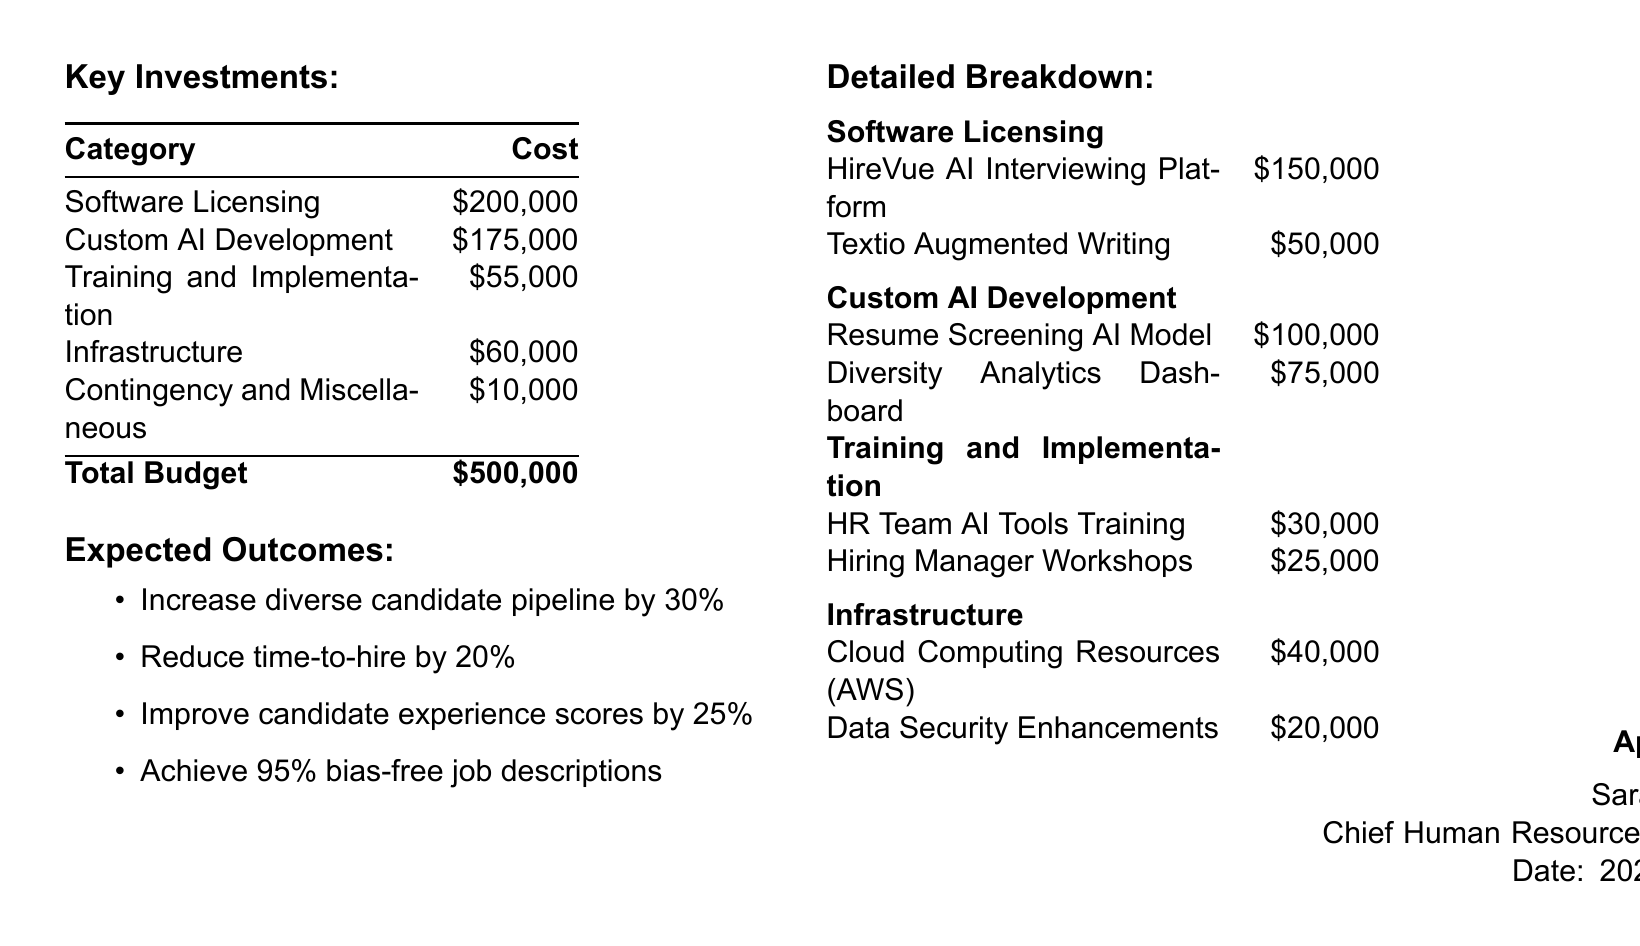What is the total budget? The total budget is presented at the bottom of the budget table.
Answer: $500,000 How much is allocated for Custom AI Development? The breakdown indicates the cost for Custom AI Development in the budget table.
Answer: $175,000 What is the cost for the HireVue AI Interviewing Platform? The cost for the HireVue AI Interviewing Platform is listed in the detailed breakdown.
Answer: $150,000 What percentage increase in the diverse candidate pipeline is expected? The expected outcome states a specific percentage increase in the diverse candidate pipeline.
Answer: 30% Who approved the budget? The approval section of the document identifies who approved the budget.
Answer: Sarah Chen What is the cost associated with Training and Implementation? The budget provides a specific figure for Training and Implementation costs.
Answer: $55,000 How much is budgeted for Data Security Enhancements? The detailed breakdown specifies the budget for Data Security Enhancements.
Answer: $20,000 What is the expected improvement in candidate experience scores? The expected outcomes provide a percentage for the improvement in candidate experience scores.
Answer: 25% What is the date of approval for the budget? The document includes the date of approval in the approval section.
Answer: 2023-09-15 